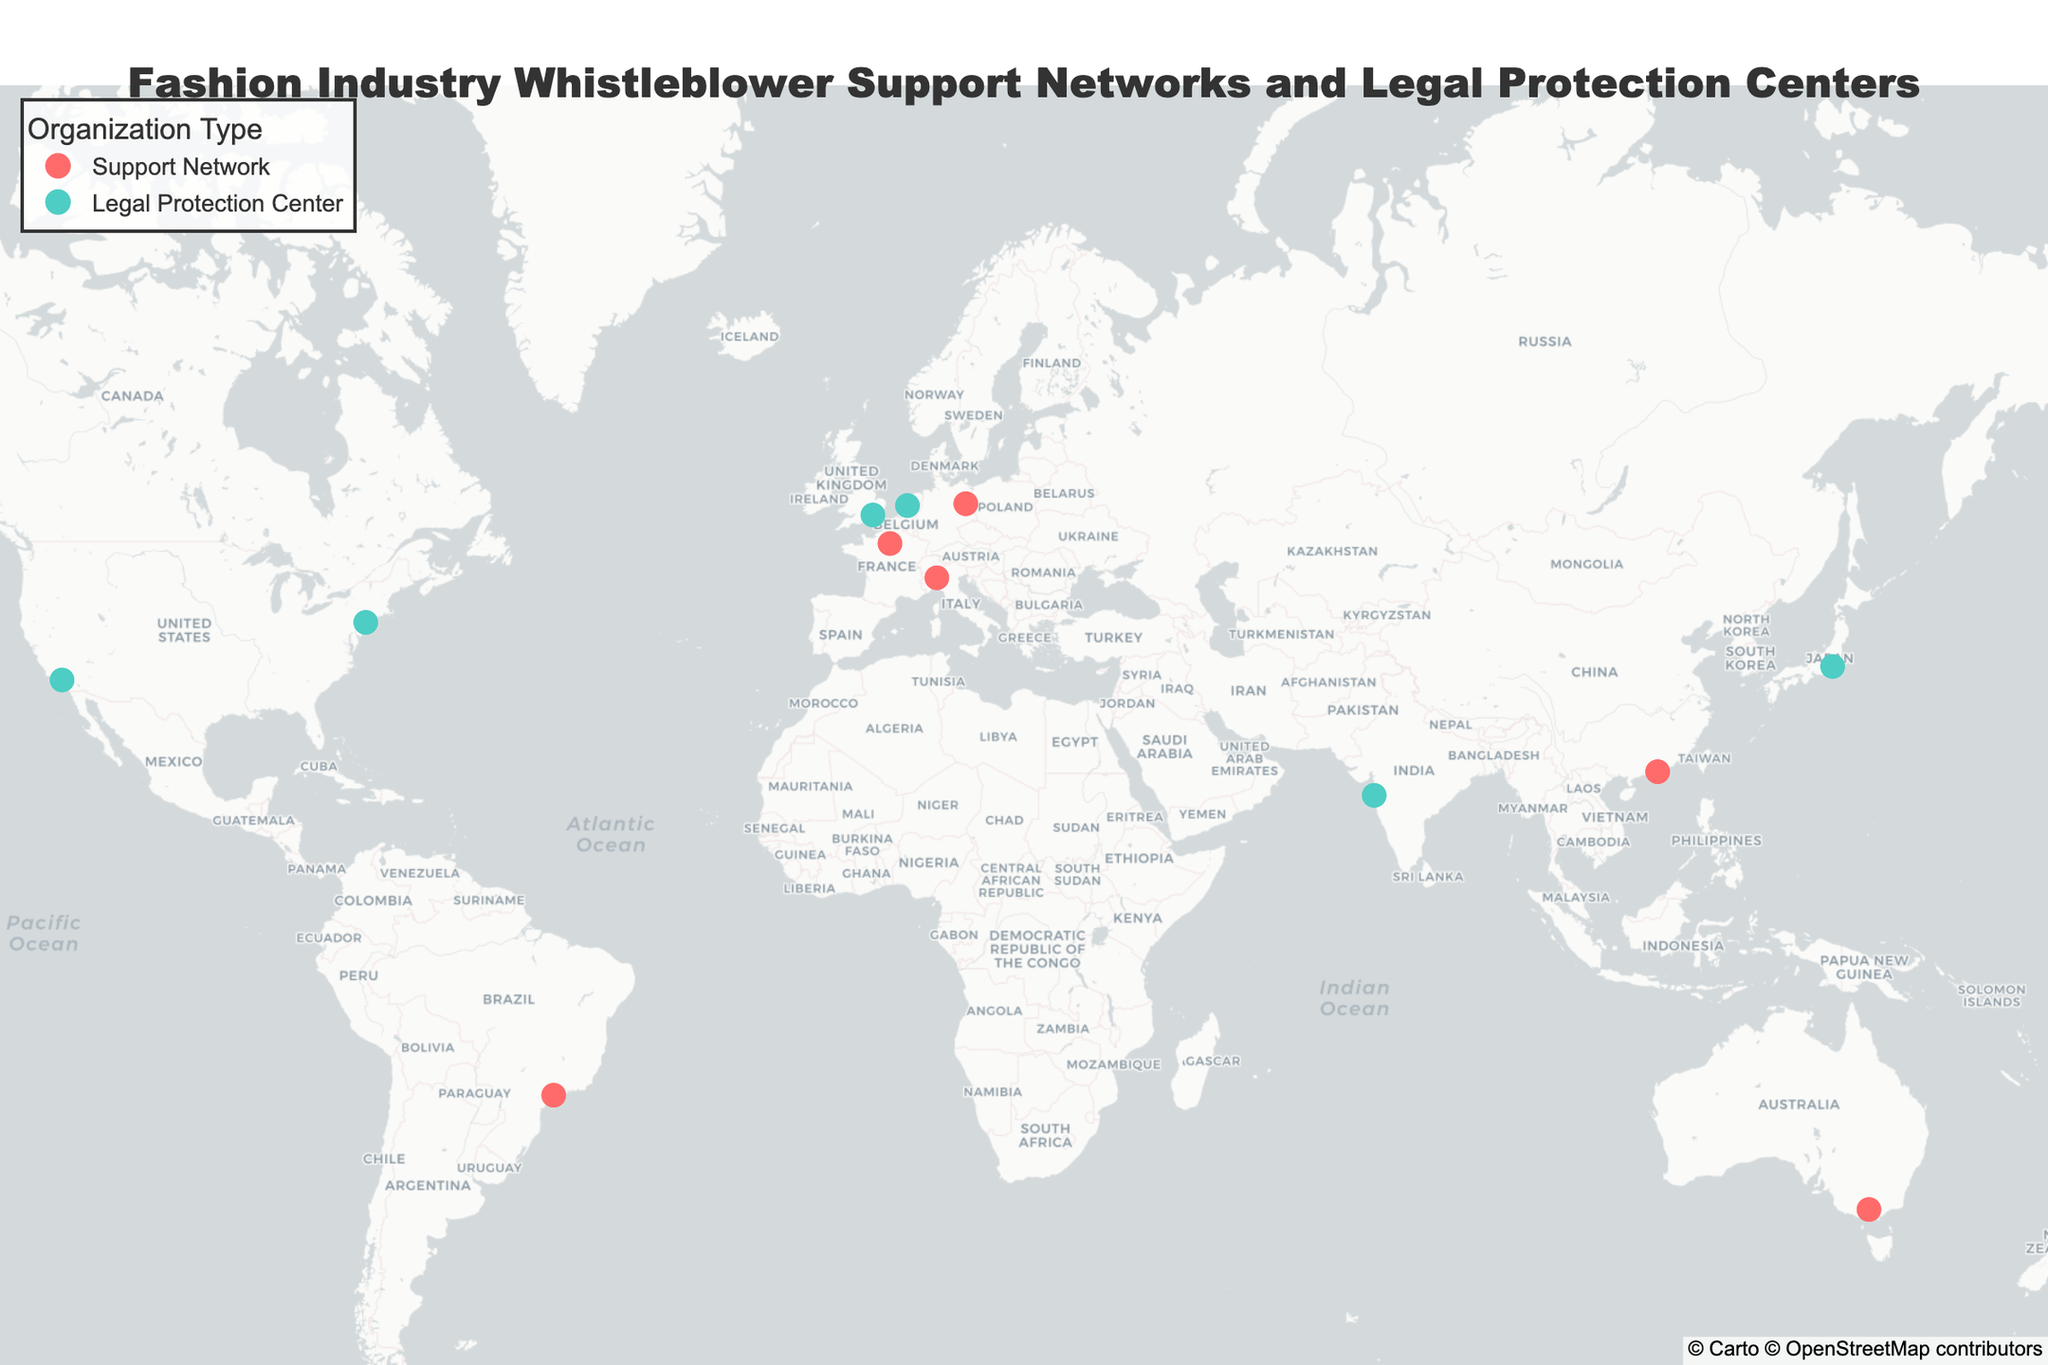How many locations are on the map? By counting all the markers representing fashion industry whistleblower support networks and legal protection centers, we find there are 12 locations.
Answer: 12 Which location is situated the furthest South? By inspecting the latitude values on the map, Melbourne has the lowest latitude at -37.8136, making it the southernmost point.
Answer: Melbourne What type of organization is more prevalent on the map? Count the occurrences of each organization type: "Support Network" and "Legal Protection Center". There are 6 support networks and 6 legal protection centers.
Answer: Both are equal What is the geographical spread of the support networks compared to the legal protection centers? By observing the map, support networks are located in Paris, Milan, Hong Kong, Berlin, Melbourne, and São Paulo. Legal protection centers are in New York, London, Los Angeles, Tokyo, Mumbai, and Amsterdam. Support networks span across Europe, Asia, and the Americas, while legal protection centers are distributed similarly but include additional representation in North America.
Answer: Similar spread Are there any continents without any representation? By checking the map and visually confirming the spread, all continents except Antarctica have representation.
Answer: Antarctica Which city has a legal protection center and is located closest to the equator? By checking the latitude values of cities with legal protection centers, Mumbai (19.0760) is the closest to the equator.
Answer: Mumbai How many locations are there in Europe? By counting the markers in European cities on the map (Paris, Milan, London, Berlin, Amsterdam), there are 5 locations in Europe.
Answer: 5 Which location has the highest longitude value? By inspecting the longitude values of all locations, Tokyo has the highest longitude (139.6503).
Answer: Tokyo How many support networks are there outside of Europe? By listing the support networks outside Europe (Hong Kong, Melbourne, São Paulo), there are three such networks.
Answer: 3 Compare the representation of legal protection centers between Asia and North America. By tallying the legal protection centers, Asia (Tokyo, Mumbai) has 2 centers, North America (New York, Los Angeles) also has 2 centers, showing equal representation in both continents.
Answer: Equal 